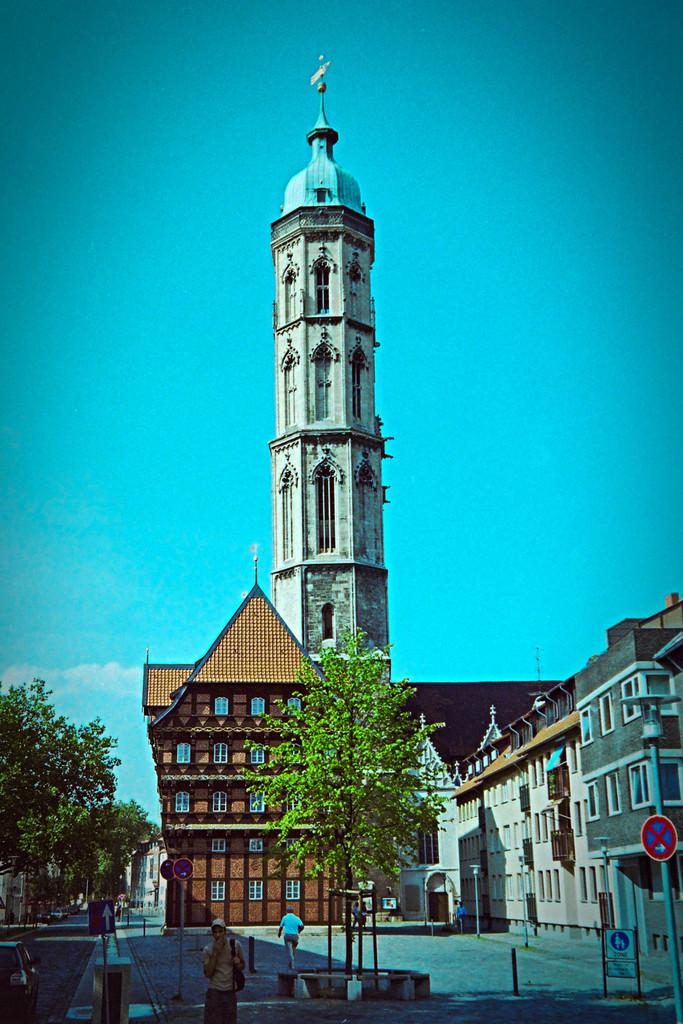What type of structures can be seen in the image? There are buildings in the image, including a tower in the center. Are there any people present in the image? Yes, there are people in the image. What other objects can be seen in the image? There are sign poles and trees in the image. What is visible in the background of the image? The sky is visible in the image. Can you see a crown on top of the tower in the image? There is no crown visible on top of the tower in the image. How many times do the people in the image kick a soccer ball? There is no soccer ball or kicking activity present in the image. 